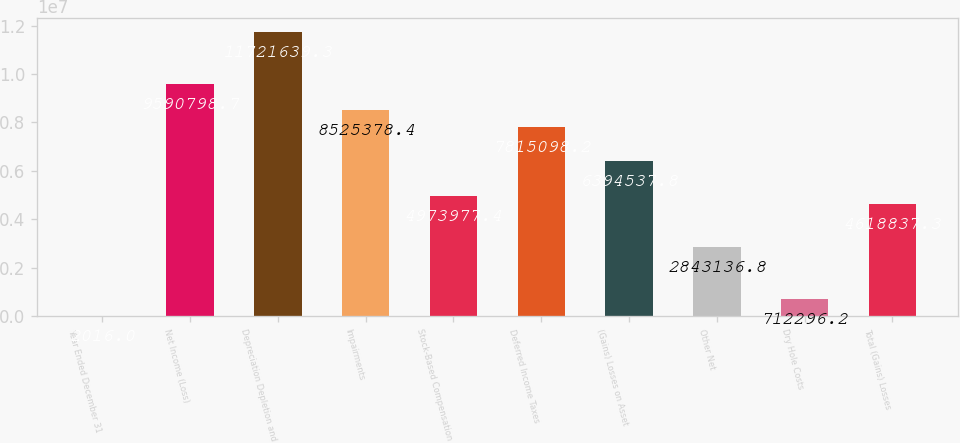Convert chart. <chart><loc_0><loc_0><loc_500><loc_500><bar_chart><fcel>Year Ended December 31<fcel>Net Income (Loss)<fcel>Depreciation Depletion and<fcel>Impairments<fcel>Stock-Based Compensation<fcel>Deferred Income Taxes<fcel>(Gains) Losses on Asset<fcel>Other Net<fcel>Dry Hole Costs<fcel>Total (Gains) Losses<nl><fcel>2016<fcel>9.5908e+06<fcel>1.17216e+07<fcel>8.52538e+06<fcel>4.97398e+06<fcel>7.8151e+06<fcel>6.39454e+06<fcel>2.84314e+06<fcel>712296<fcel>4.61884e+06<nl></chart> 